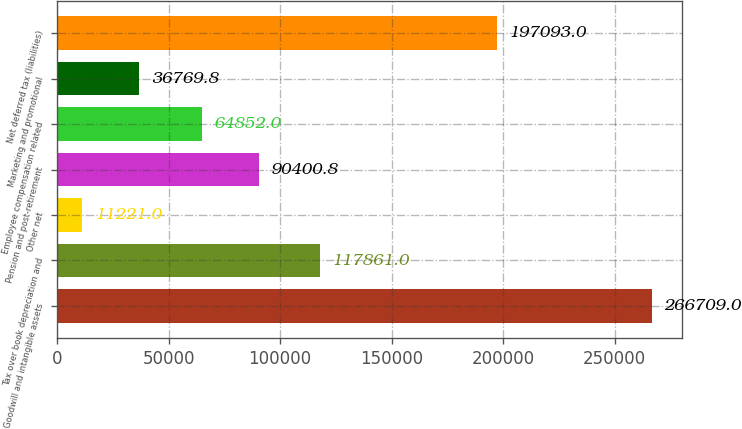Convert chart. <chart><loc_0><loc_0><loc_500><loc_500><bar_chart><fcel>Goodwill and intangible assets<fcel>Tax over book depreciation and<fcel>Other net<fcel>Pension and post-retirement<fcel>Employee compensation related<fcel>Marketing and promotional<fcel>Net deferred tax (liabilities)<nl><fcel>266709<fcel>117861<fcel>11221<fcel>90400.8<fcel>64852<fcel>36769.8<fcel>197093<nl></chart> 